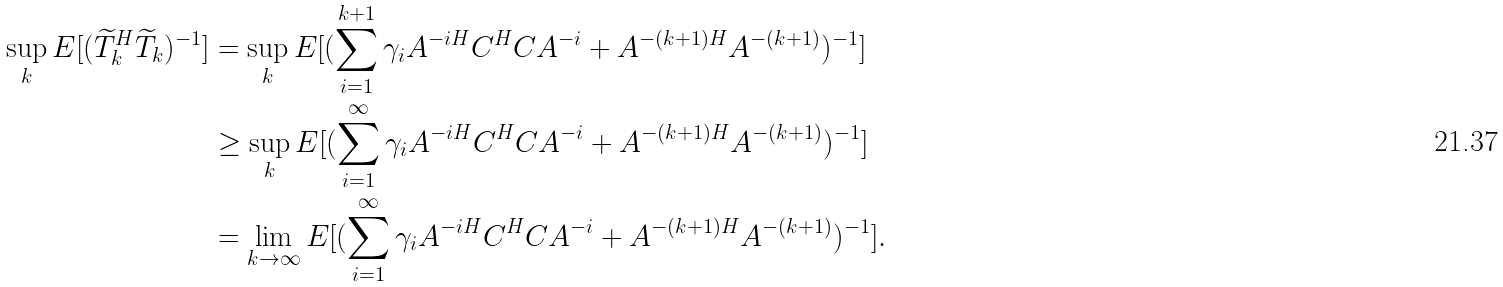Convert formula to latex. <formula><loc_0><loc_0><loc_500><loc_500>\sup _ { k } E [ ( \widetilde { T } _ { k } ^ { H } \widetilde { T } _ { k } ) ^ { - 1 } ] & = \sup _ { k } E [ ( \sum _ { i = 1 } ^ { k + 1 } \gamma _ { i } A ^ { - i H } C ^ { H } C A ^ { - i } + A ^ { - ( k + 1 ) H } A ^ { - ( k + 1 ) } ) ^ { - 1 } ] \\ & \geq \sup _ { k } E [ ( \sum _ { i = 1 } ^ { \infty } \gamma _ { i } A ^ { - i H } C ^ { H } C A ^ { - i } + A ^ { - ( k + 1 ) H } A ^ { - ( k + 1 ) } ) ^ { - 1 } ] \\ & = \lim _ { k \rightarrow \infty } E [ ( \sum _ { i = 1 } ^ { \infty } \gamma _ { i } A ^ { - i H } C ^ { H } C A ^ { - i } + A ^ { - ( k + 1 ) H } A ^ { - ( k + 1 ) } ) ^ { - 1 } ] .</formula> 